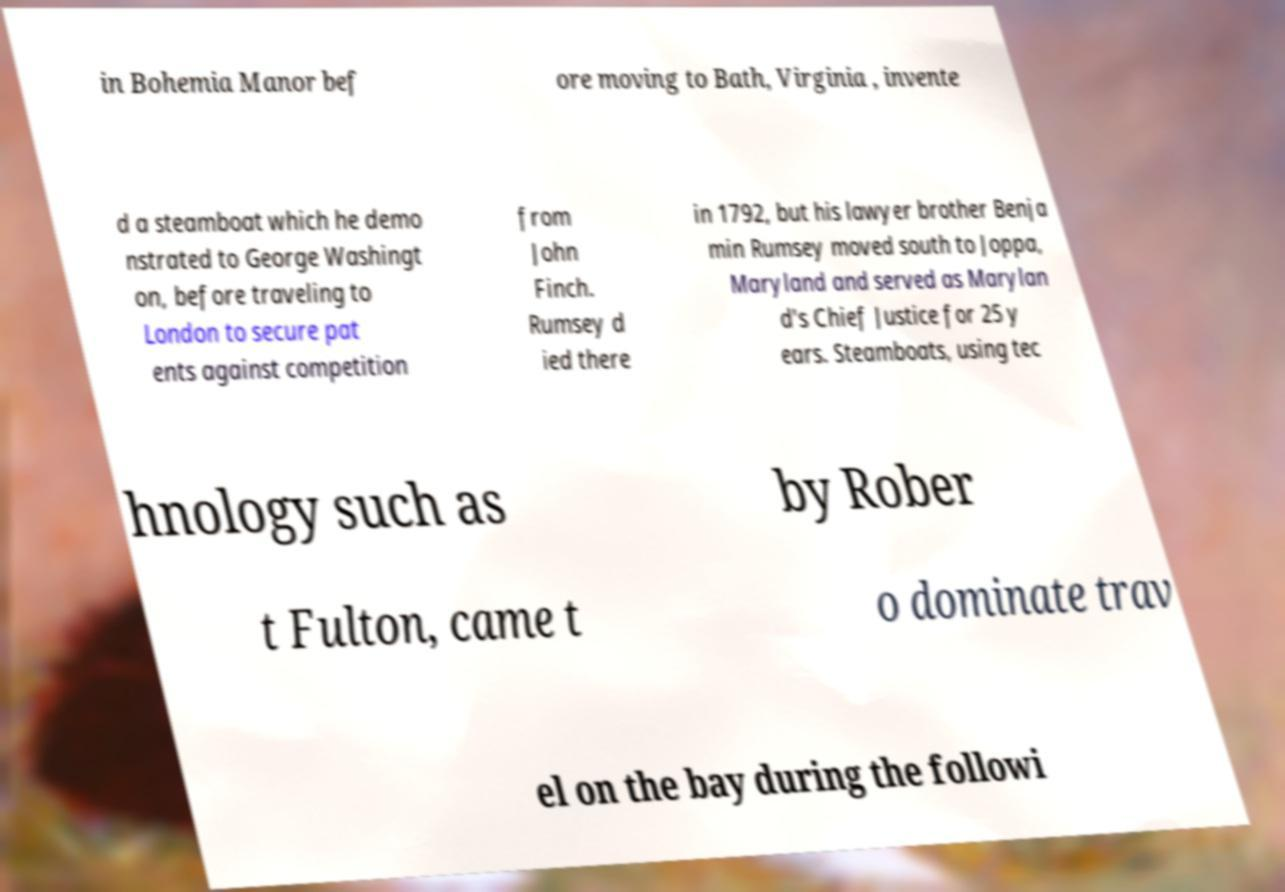Could you extract and type out the text from this image? in Bohemia Manor bef ore moving to Bath, Virginia , invente d a steamboat which he demo nstrated to George Washingt on, before traveling to London to secure pat ents against competition from John Finch. Rumsey d ied there in 1792, but his lawyer brother Benja min Rumsey moved south to Joppa, Maryland and served as Marylan d's Chief Justice for 25 y ears. Steamboats, using tec hnology such as by Rober t Fulton, came t o dominate trav el on the bay during the followi 